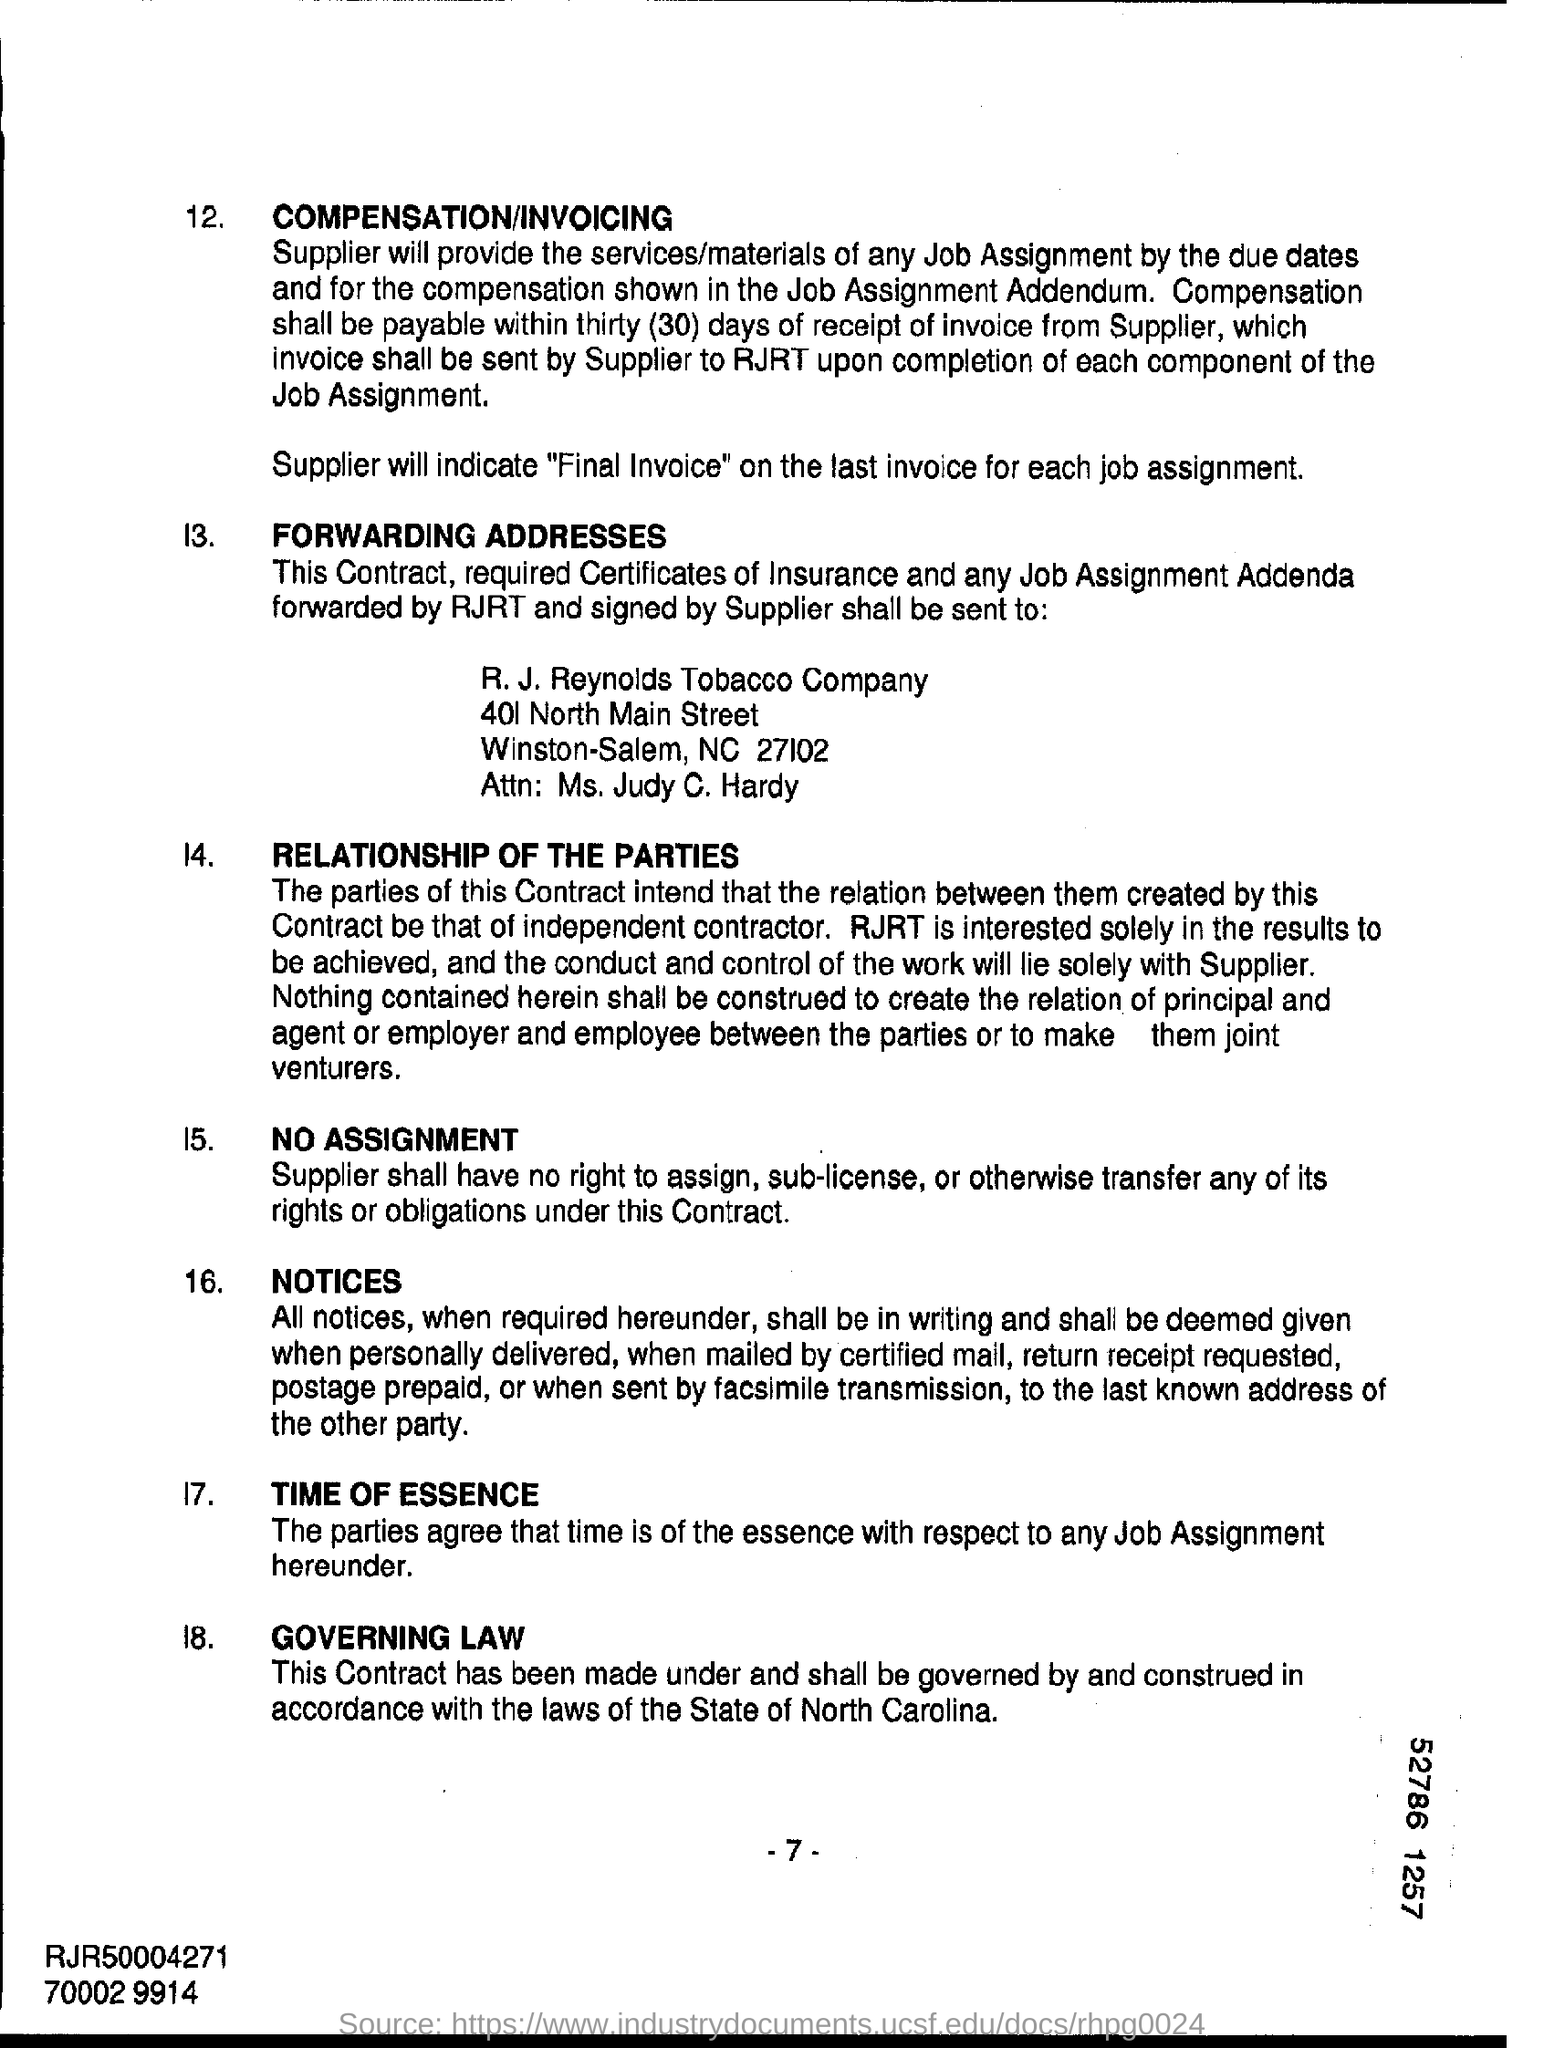In which state is r.j reynolds tobacco company at ?
Provide a short and direct response. NC. Within how many days compensation shall be paid ?
Provide a succinct answer. 30. What will supplier indicate on the last invoice for each job assignment ?
Offer a terse response. Final invoice. Under which state will this contract be made and shall be governed by?
Keep it short and to the point. State of North Carolina. 